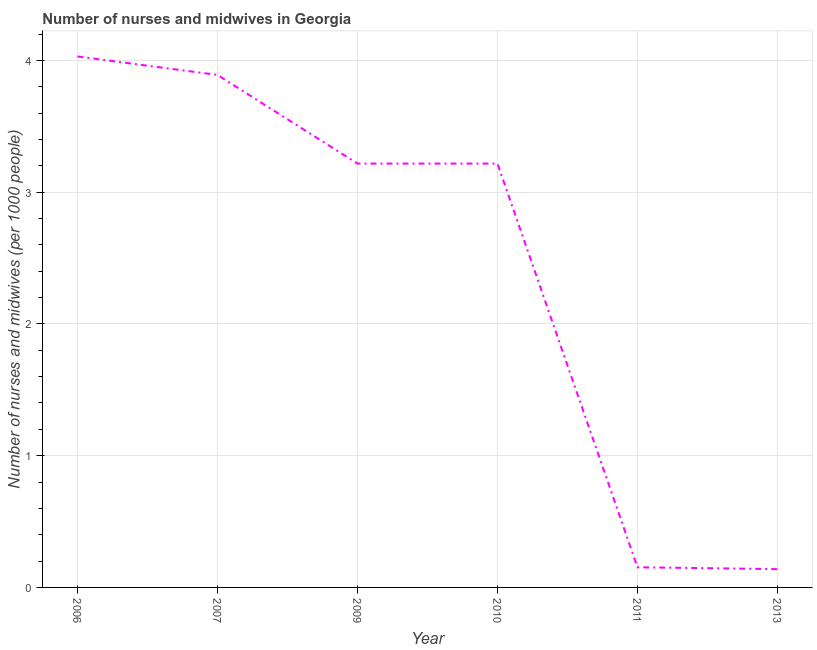What is the number of nurses and midwives in 2011?
Offer a very short reply. 0.15. Across all years, what is the maximum number of nurses and midwives?
Give a very brief answer. 4.03. Across all years, what is the minimum number of nurses and midwives?
Your answer should be very brief. 0.14. What is the sum of the number of nurses and midwives?
Give a very brief answer. 14.65. What is the difference between the number of nurses and midwives in 2007 and 2013?
Your answer should be very brief. 3.75. What is the average number of nurses and midwives per year?
Your answer should be very brief. 2.44. What is the median number of nurses and midwives?
Your answer should be very brief. 3.22. What is the ratio of the number of nurses and midwives in 2006 to that in 2013?
Your answer should be very brief. 28.99. Is the difference between the number of nurses and midwives in 2006 and 2007 greater than the difference between any two years?
Your answer should be very brief. No. What is the difference between the highest and the second highest number of nurses and midwives?
Provide a short and direct response. 0.14. What is the difference between the highest and the lowest number of nurses and midwives?
Your answer should be compact. 3.89. Does the number of nurses and midwives monotonically increase over the years?
Your answer should be compact. No. How many lines are there?
Provide a succinct answer. 1. What is the difference between two consecutive major ticks on the Y-axis?
Your answer should be compact. 1. Are the values on the major ticks of Y-axis written in scientific E-notation?
Give a very brief answer. No. Does the graph contain any zero values?
Your answer should be compact. No. What is the title of the graph?
Provide a short and direct response. Number of nurses and midwives in Georgia. What is the label or title of the Y-axis?
Give a very brief answer. Number of nurses and midwives (per 1000 people). What is the Number of nurses and midwives (per 1000 people) of 2006?
Keep it short and to the point. 4.03. What is the Number of nurses and midwives (per 1000 people) in 2007?
Your response must be concise. 3.89. What is the Number of nurses and midwives (per 1000 people) of 2009?
Provide a short and direct response. 3.22. What is the Number of nurses and midwives (per 1000 people) of 2010?
Offer a terse response. 3.22. What is the Number of nurses and midwives (per 1000 people) of 2011?
Provide a short and direct response. 0.15. What is the Number of nurses and midwives (per 1000 people) in 2013?
Your answer should be very brief. 0.14. What is the difference between the Number of nurses and midwives (per 1000 people) in 2006 and 2007?
Offer a terse response. 0.14. What is the difference between the Number of nurses and midwives (per 1000 people) in 2006 and 2009?
Your response must be concise. 0.81. What is the difference between the Number of nurses and midwives (per 1000 people) in 2006 and 2010?
Keep it short and to the point. 0.81. What is the difference between the Number of nurses and midwives (per 1000 people) in 2006 and 2011?
Provide a succinct answer. 3.88. What is the difference between the Number of nurses and midwives (per 1000 people) in 2006 and 2013?
Provide a short and direct response. 3.89. What is the difference between the Number of nurses and midwives (per 1000 people) in 2007 and 2009?
Offer a terse response. 0.67. What is the difference between the Number of nurses and midwives (per 1000 people) in 2007 and 2010?
Your response must be concise. 0.67. What is the difference between the Number of nurses and midwives (per 1000 people) in 2007 and 2011?
Your answer should be compact. 3.74. What is the difference between the Number of nurses and midwives (per 1000 people) in 2007 and 2013?
Your answer should be very brief. 3.75. What is the difference between the Number of nurses and midwives (per 1000 people) in 2009 and 2010?
Offer a very short reply. 0. What is the difference between the Number of nurses and midwives (per 1000 people) in 2009 and 2011?
Give a very brief answer. 3.06. What is the difference between the Number of nurses and midwives (per 1000 people) in 2009 and 2013?
Ensure brevity in your answer.  3.08. What is the difference between the Number of nurses and midwives (per 1000 people) in 2010 and 2011?
Make the answer very short. 3.06. What is the difference between the Number of nurses and midwives (per 1000 people) in 2010 and 2013?
Your answer should be compact. 3.08. What is the difference between the Number of nurses and midwives (per 1000 people) in 2011 and 2013?
Your answer should be very brief. 0.01. What is the ratio of the Number of nurses and midwives (per 1000 people) in 2006 to that in 2007?
Your response must be concise. 1.04. What is the ratio of the Number of nurses and midwives (per 1000 people) in 2006 to that in 2009?
Provide a succinct answer. 1.25. What is the ratio of the Number of nurses and midwives (per 1000 people) in 2006 to that in 2010?
Provide a succinct answer. 1.25. What is the ratio of the Number of nurses and midwives (per 1000 people) in 2006 to that in 2011?
Make the answer very short. 26.34. What is the ratio of the Number of nurses and midwives (per 1000 people) in 2006 to that in 2013?
Keep it short and to the point. 28.99. What is the ratio of the Number of nurses and midwives (per 1000 people) in 2007 to that in 2009?
Keep it short and to the point. 1.21. What is the ratio of the Number of nurses and midwives (per 1000 people) in 2007 to that in 2010?
Your answer should be very brief. 1.21. What is the ratio of the Number of nurses and midwives (per 1000 people) in 2007 to that in 2011?
Give a very brief answer. 25.43. What is the ratio of the Number of nurses and midwives (per 1000 people) in 2007 to that in 2013?
Keep it short and to the point. 27.99. What is the ratio of the Number of nurses and midwives (per 1000 people) in 2009 to that in 2011?
Your answer should be compact. 21.03. What is the ratio of the Number of nurses and midwives (per 1000 people) in 2009 to that in 2013?
Provide a succinct answer. 23.14. What is the ratio of the Number of nurses and midwives (per 1000 people) in 2010 to that in 2011?
Offer a terse response. 21.03. What is the ratio of the Number of nurses and midwives (per 1000 people) in 2010 to that in 2013?
Give a very brief answer. 23.14. What is the ratio of the Number of nurses and midwives (per 1000 people) in 2011 to that in 2013?
Provide a succinct answer. 1.1. 